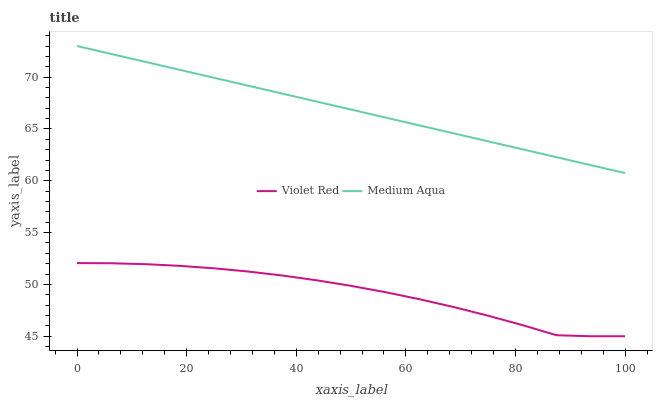Does Medium Aqua have the minimum area under the curve?
Answer yes or no. No. Is Medium Aqua the roughest?
Answer yes or no. No. Does Medium Aqua have the lowest value?
Answer yes or no. No. Is Violet Red less than Medium Aqua?
Answer yes or no. Yes. Is Medium Aqua greater than Violet Red?
Answer yes or no. Yes. Does Violet Red intersect Medium Aqua?
Answer yes or no. No. 